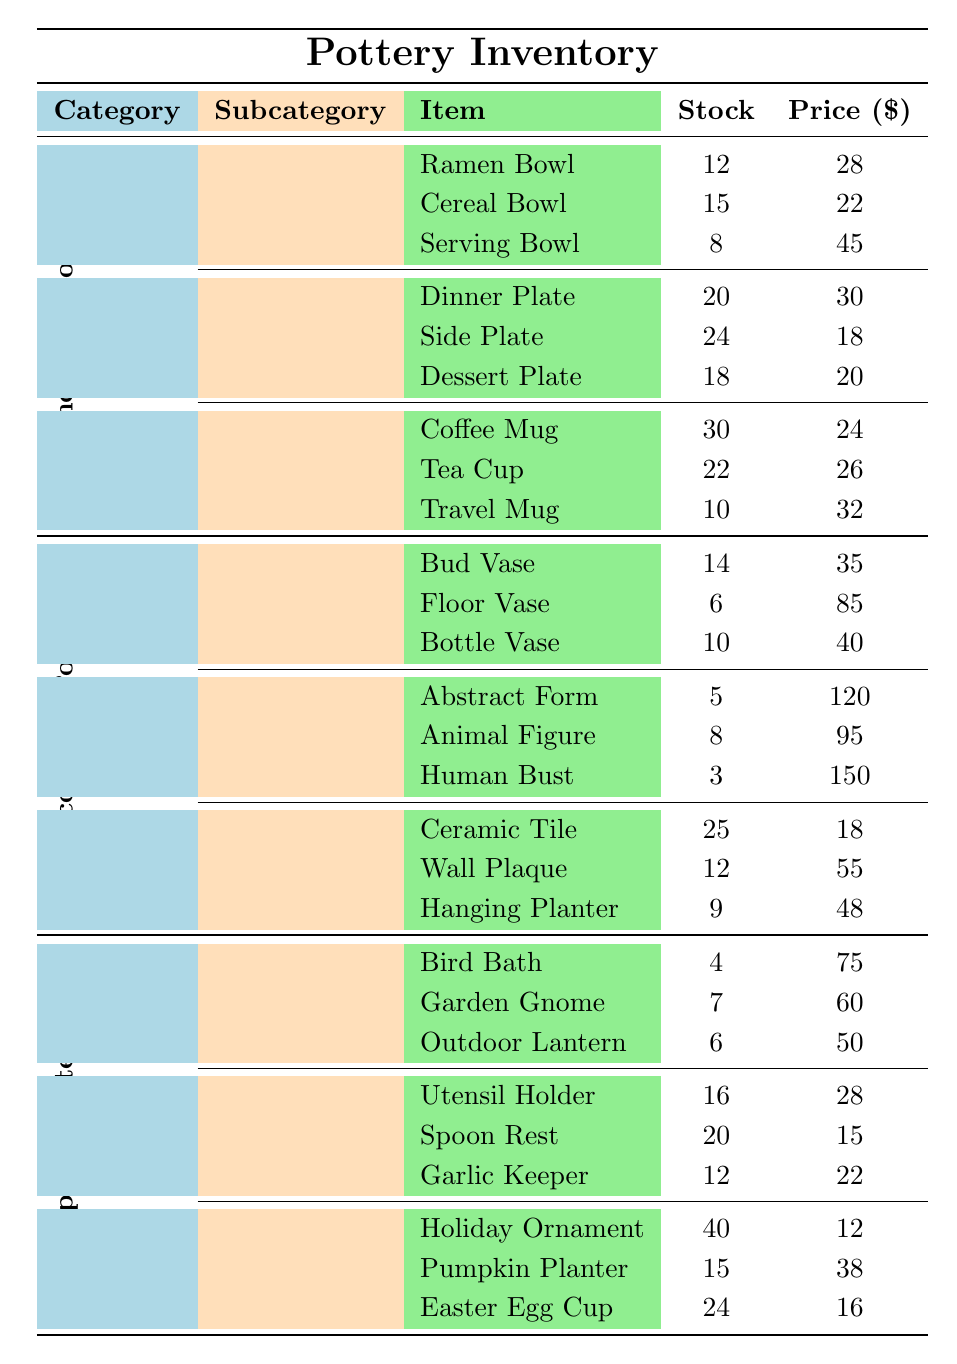What is the stock of the Cereal Bowl? The table shows the stock information for the Cereal Bowl, which is located under the Functional Pottery category and the Bowls subcategory. The stock for the Cereal Bowl is listed as 15.
Answer: 15 How many items are available in the Decorative Pottery category? In the Decorative Pottery category, we have 3 subcategories (Vases, Sculptures, and Wall Art), each containing 3 items. Therefore, we can calculate the total items as 3 (Vases) + 3 (Sculptures) + 3 (Wall Art) = 9 items.
Answer: 9 What is the price of the outdoor lantern? The Outdoor Lantern is listed under the Specialty Items category and the Garden subcategory. The price is given as 50.
Answer: 50 Which has a higher stock, the Serving Bowl or the Side Plate? The stock for the Serving Bowl is 8, while the stock for the Side Plate is 24. Since 24 is greater than 8, the Side Plate has a higher stock than the Serving Bowl.
Answer: Side Plate What is the total stock of all items in the Kitchenware subcategory? In the Kitchenware subcategory, we have 3 items: Utensil Holder (16), Spoon Rest (20), and Garlic Keeper (12). Summing these amounts gives us 16 + 20 + 12 = 48.
Answer: 48 Is there a sculpture with a stock of 3 units? The table lists the Human Bust under the Sculptures subcategory with a stock of 3. Therefore, there is indeed a sculpture with a stock of 3 units.
Answer: Yes Which is the most expensive item in the inventory? From examining the table, the most expensive item is the Human Bust at a price of 150. No other items have a higher price.
Answer: 150 What is the average price of items in the Bowls subcategory? In the Bowls subcategory, the prices are Ramen Bowl (28), Cereal Bowl (22), and Serving Bowl (45). Adding these prices gives 28 + 22 + 45 = 95, and dividing by the number of items (3) gives an average price of 95/3 = 31.67.
Answer: 31.67 How many more Garden Gnomes are there compared to Bird Baths? The stock for Garden Gnomes is 7, while for Bird Baths it is 4. The difference is calculated as 7 - 4 = 3, indicating there are 3 more Garden Gnomes.
Answer: 3 What is the total revenue if all Holiday Ornaments are sold? The price of each Holiday Ornament is 12, and there are 40 in stock. The total revenue is calculated by multiplying the price by the stock: 12 * 40 = 480.
Answer: 480 